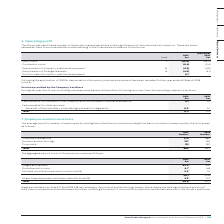According to Auto Trader's financial document, What does the average monthly number of employees include or exclude? including Executive Directors but excluding third-party contractors. The document states: "The average monthly number of employees (including Executive Directors but excluding third-party contractors) employed by the Group was as follows:..." Also, What is the total average number of employees employed in 2019? According to the financial document, 802. The relevant text states: "Total 802 822..." Also, What are the categories of employees listed in the table? The document contains multiple relevant values: Customer operations, Product and technology, Corporate. From the document: "Corporate 115 130 Customer operations 370 380 Product and technology 317 312..." Additionally, In which year was Product and technology larger? According to the financial document, 2019. The relevant text states: "2019 £m 2018 £m..." Also, can you calculate: What was the change in Corporate in 2019 from 2018? Based on the calculation: 115-130, the result is -15. This is based on the information: "Corporate 115 130 Corporate 115 130..." The key data points involved are: 115, 130. Also, can you calculate: What was the percentage change in Corporate in 2019 from 2018? To answer this question, I need to perform calculations using the financial data. The calculation is: (115-130)/130, which equals -11.54 (percentage). This is based on the information: "Corporate 115 130 Corporate 115 130..." The key data points involved are: 115, 130. 